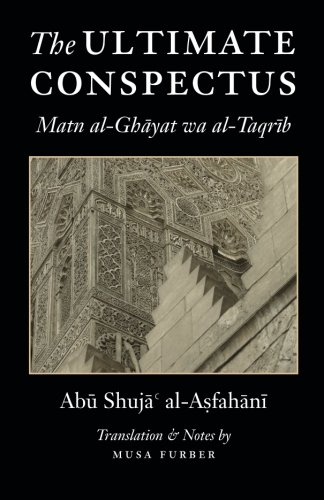Is this book related to Religion & Spirituality? Yes, this book is deeply rooted in the realm of Religion & Spirituality, offering insights into Islamic legal and ethical norms. 